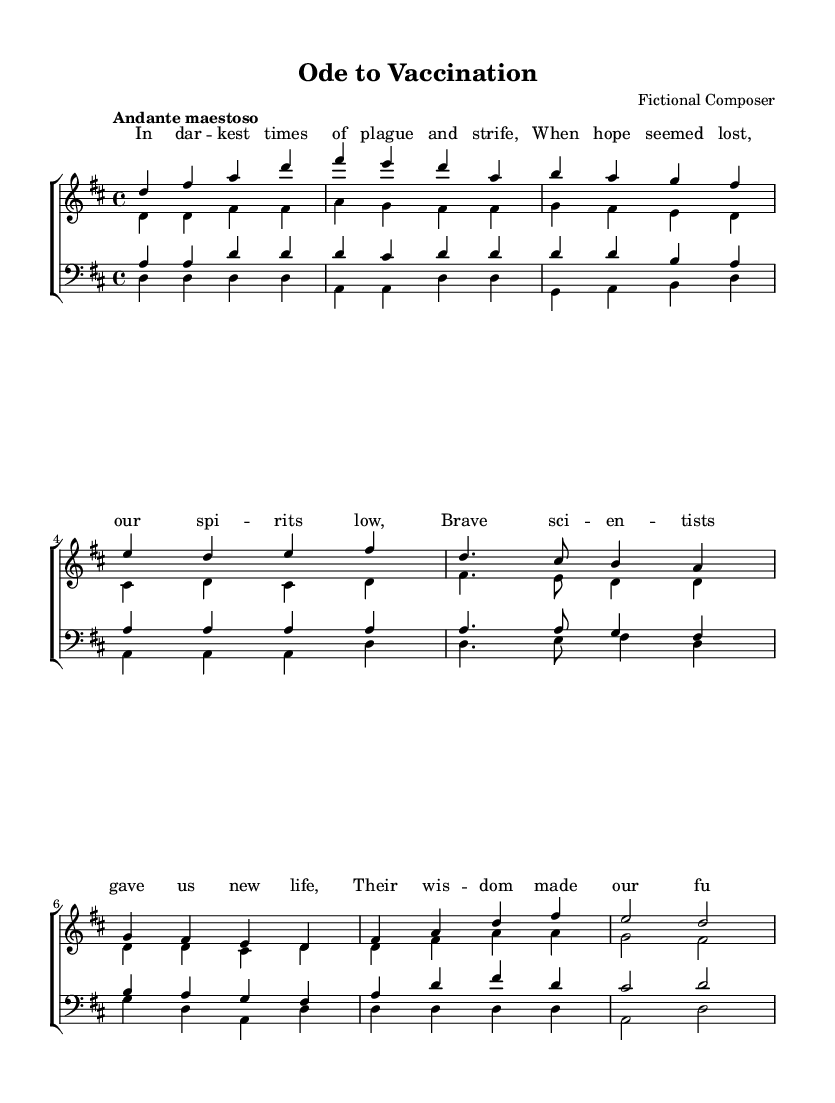What is the key signature of this music? The key signature can be identified by looking at the beginning of the staff where it shows sharps or flats. In this piece, it is D major, which has two sharps (F# and C#).
Answer: D major What is the time signature of this music? The time signature is found in the staff before the notes begin, indicating how many beats are in each measure. This piece has a time signature of 4/4, which means there are 4 beats per measure and a quarter note gets one beat.
Answer: 4/4 What tempo marking is indicated? The tempo marking is located at the beginning of the score, where it specifies how fast or slow the piece should be played. In this case, the tempo is marked as "Andante maestoso," which sets a moderate and majestic pace.
Answer: Andante maestoso What texture is primarily used in this choral work? The texture can be inferred from the way voices are arranged and interact. In this piece, there are four main vocal parts singing together, indicating a polyphonic texture typical of choral works from the Romantic era.
Answer: Polyphonic How many verses are present in the score? Counting the sections marked in the score indicates the number of verses. There are two distinct sections labeled as "Verse" followed by a "Chorus," indicating there are two verses present in the composition.
Answer: 2 What theme is celebrated in the lyrics? The theme can be identified by analyzing the words provided in the lyrics, which refer to the impact of science on disease and the triumph of research. The lyrics celebrate the achievements in public health and medicine.
Answer: Triumph of science over disease 